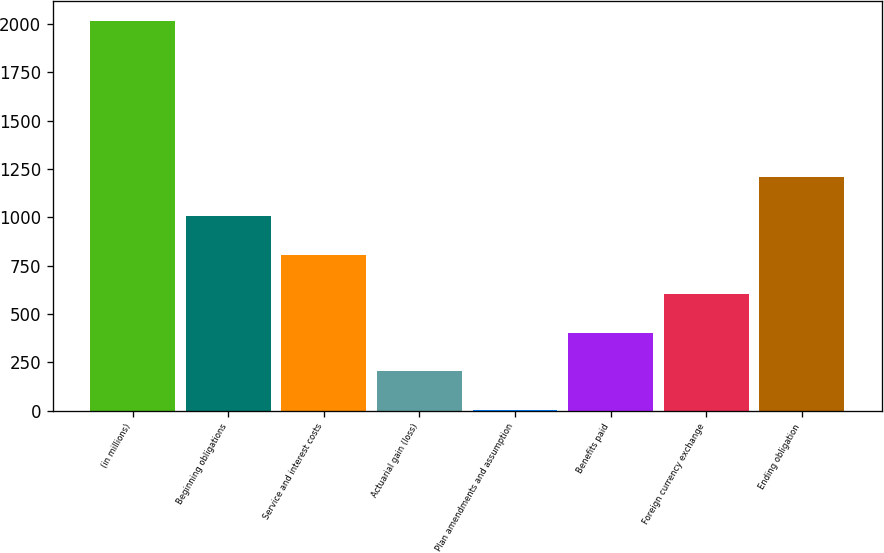<chart> <loc_0><loc_0><loc_500><loc_500><bar_chart><fcel>(in millions)<fcel>Beginning obligations<fcel>Service and interest costs<fcel>Actuarial gain (loss)<fcel>Plan amendments and assumption<fcel>Benefits paid<fcel>Foreign currency exchange<fcel>Ending obligation<nl><fcel>2017<fcel>1009<fcel>807.4<fcel>202.6<fcel>1<fcel>404.2<fcel>605.8<fcel>1210.6<nl></chart> 